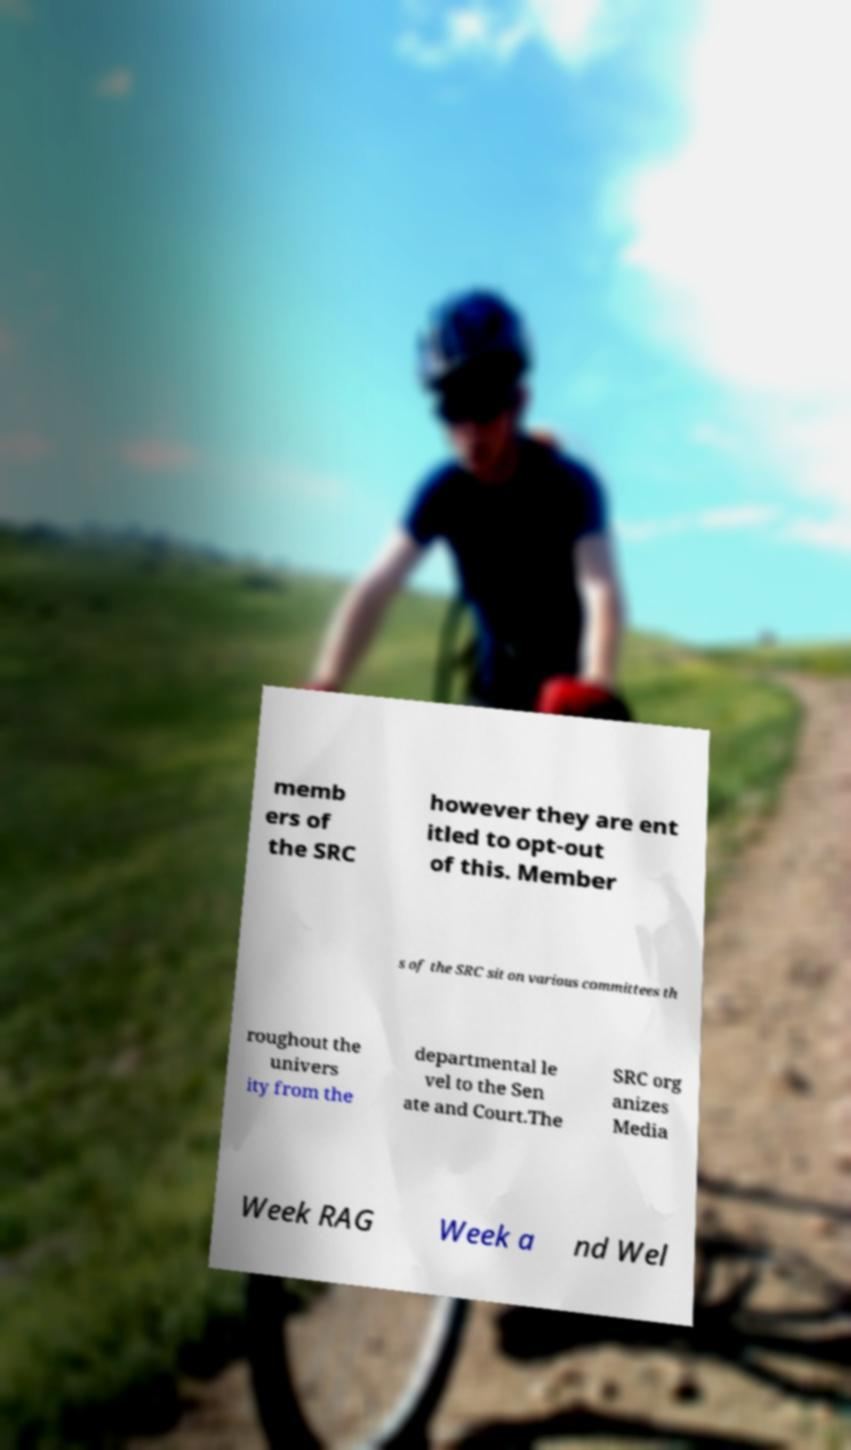There's text embedded in this image that I need extracted. Can you transcribe it verbatim? memb ers of the SRC however they are ent itled to opt-out of this. Member s of the SRC sit on various committees th roughout the univers ity from the departmental le vel to the Sen ate and Court.The SRC org anizes Media Week RAG Week a nd Wel 